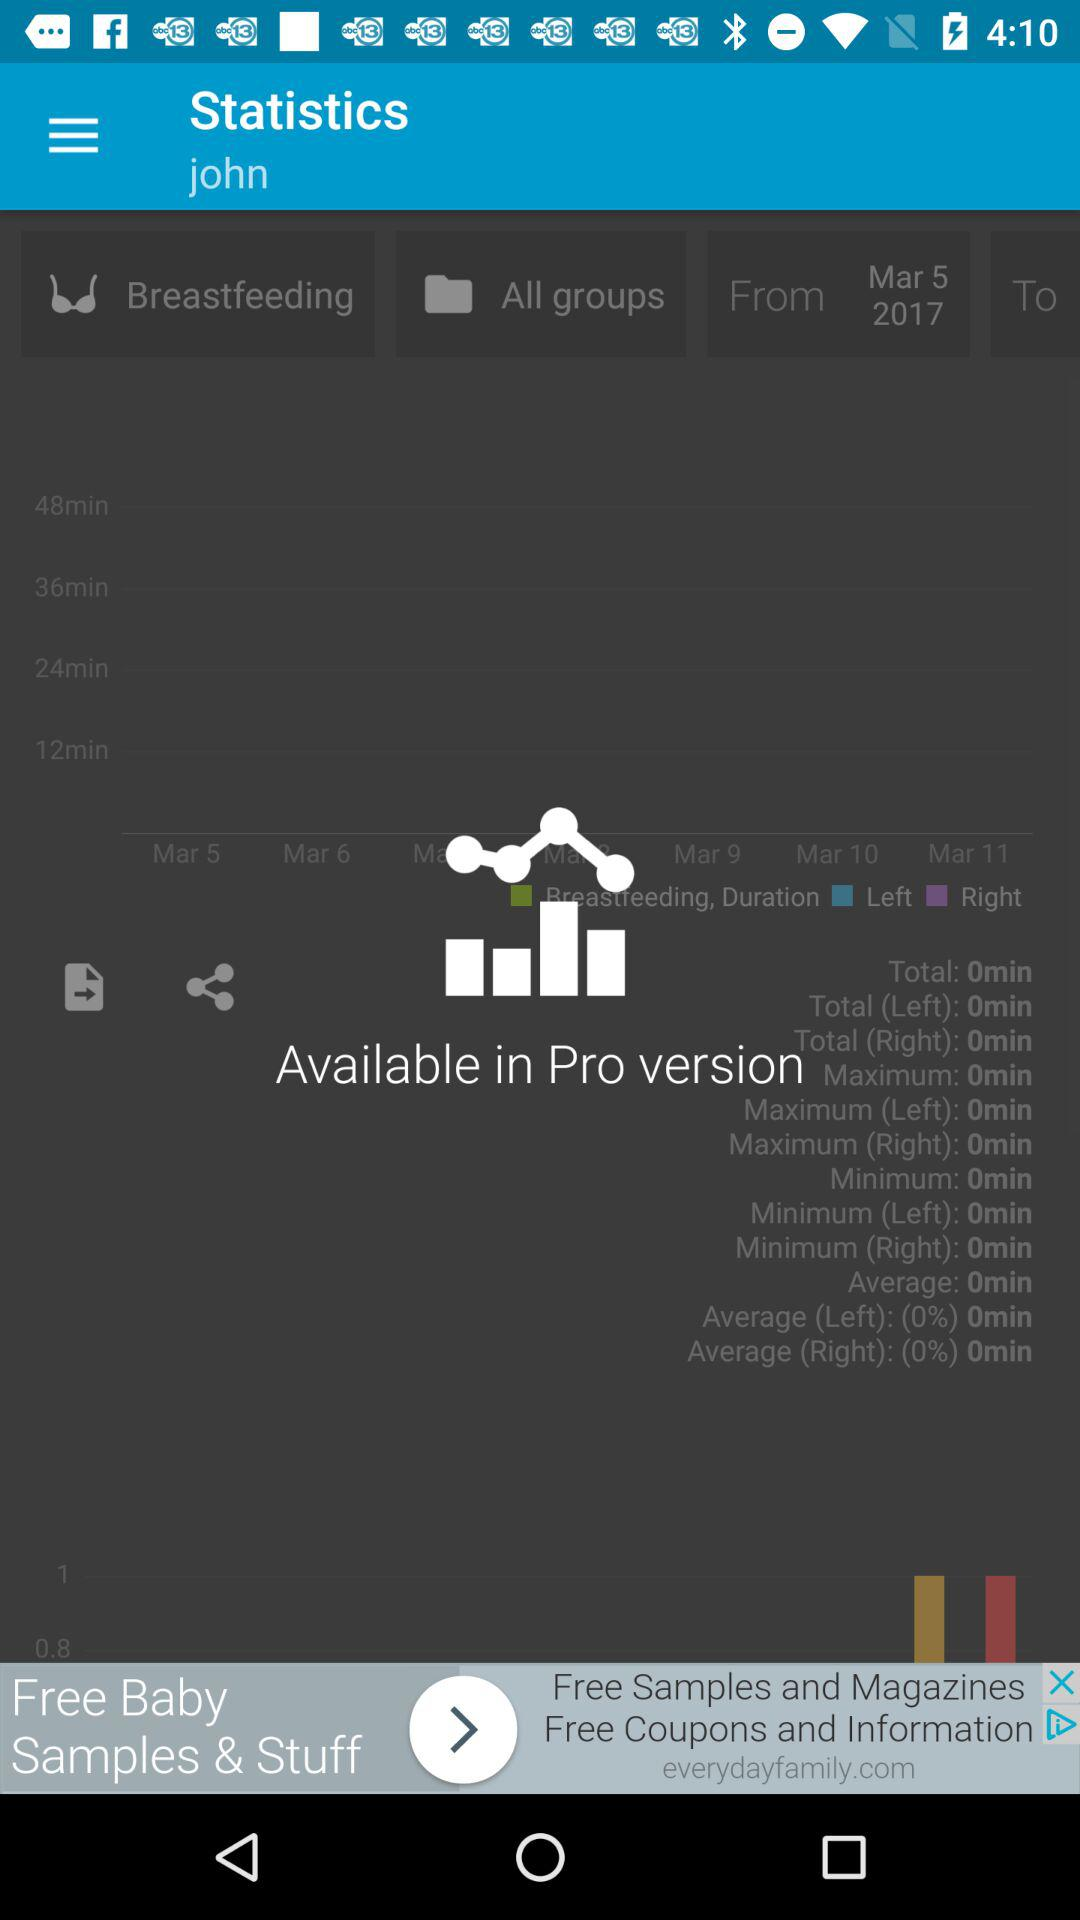What is the user name? The user name is John. 